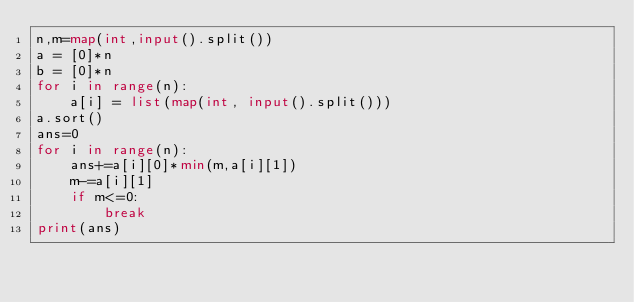<code> <loc_0><loc_0><loc_500><loc_500><_Python_>n,m=map(int,input().split())
a = [0]*n
b = [0]*n
for i in range(n):
    a[i] = list(map(int, input().split()))
a.sort()
ans=0
for i in range(n):
    ans+=a[i][0]*min(m,a[i][1])
    m-=a[i][1]
    if m<=0:
        break
print(ans)</code> 